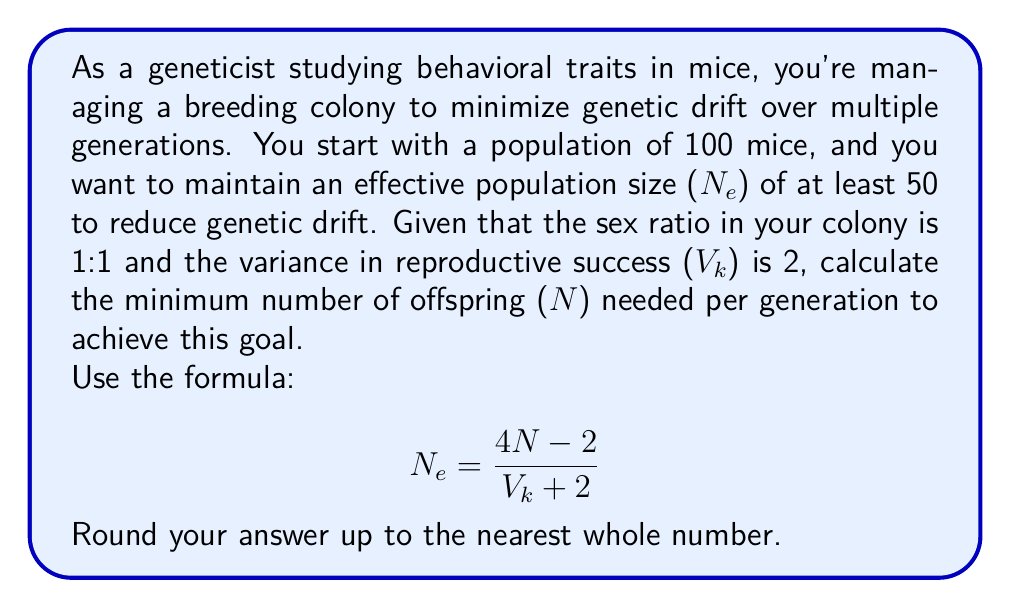Could you help me with this problem? Let's approach this step-by-step:

1) We are given:
   - Desired effective population size ($N_e$) ≥ 50
   - Variance in reproductive success ($V_k$) = 2
   - We need to find the minimum number of offspring ($N$)

2) We'll use the formula: $$N_e = \frac{4N - 2}{V_k + 2}$$

3) Let's substitute the known values and set up an inequality:
   $$50 \leq \frac{4N - 2}{2 + 2}$$

4) Simplify the denominator:
   $$50 \leq \frac{4N - 2}{4}$$

5) Multiply both sides by 4:
   $$200 \leq 4N - 2$$

6) Add 2 to both sides:
   $$202 \leq 4N$$

7) Divide both sides by 4:
   $$50.5 \leq N$$

8) Since we need the minimum number of offspring and it must be a whole number, we round up:
   $$N = 51$$

Therefore, you need at least 51 offspring per generation to maintain an effective population size of at least 50 and minimize genetic drift in your mouse breeding colony.
Answer: 51 offspring 